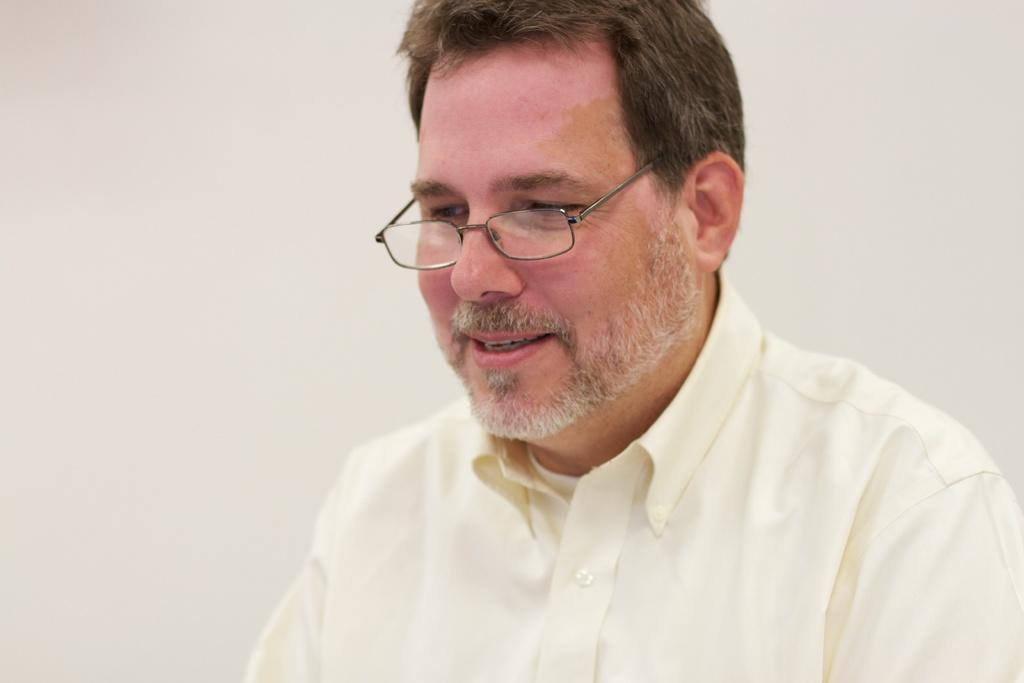Who or what is the main subject in the image? There is a person in the image. What is the person wearing on their upper body? The person is wearing a shirt. What accessory is the person wearing on their face? The person is wearing spectacles. What color is the background of the image? The background of the image is white. What type of riddle can be solved by touching the bee in the image? There is no bee present in the image, and therefore no riddle can be solved by touching it. 